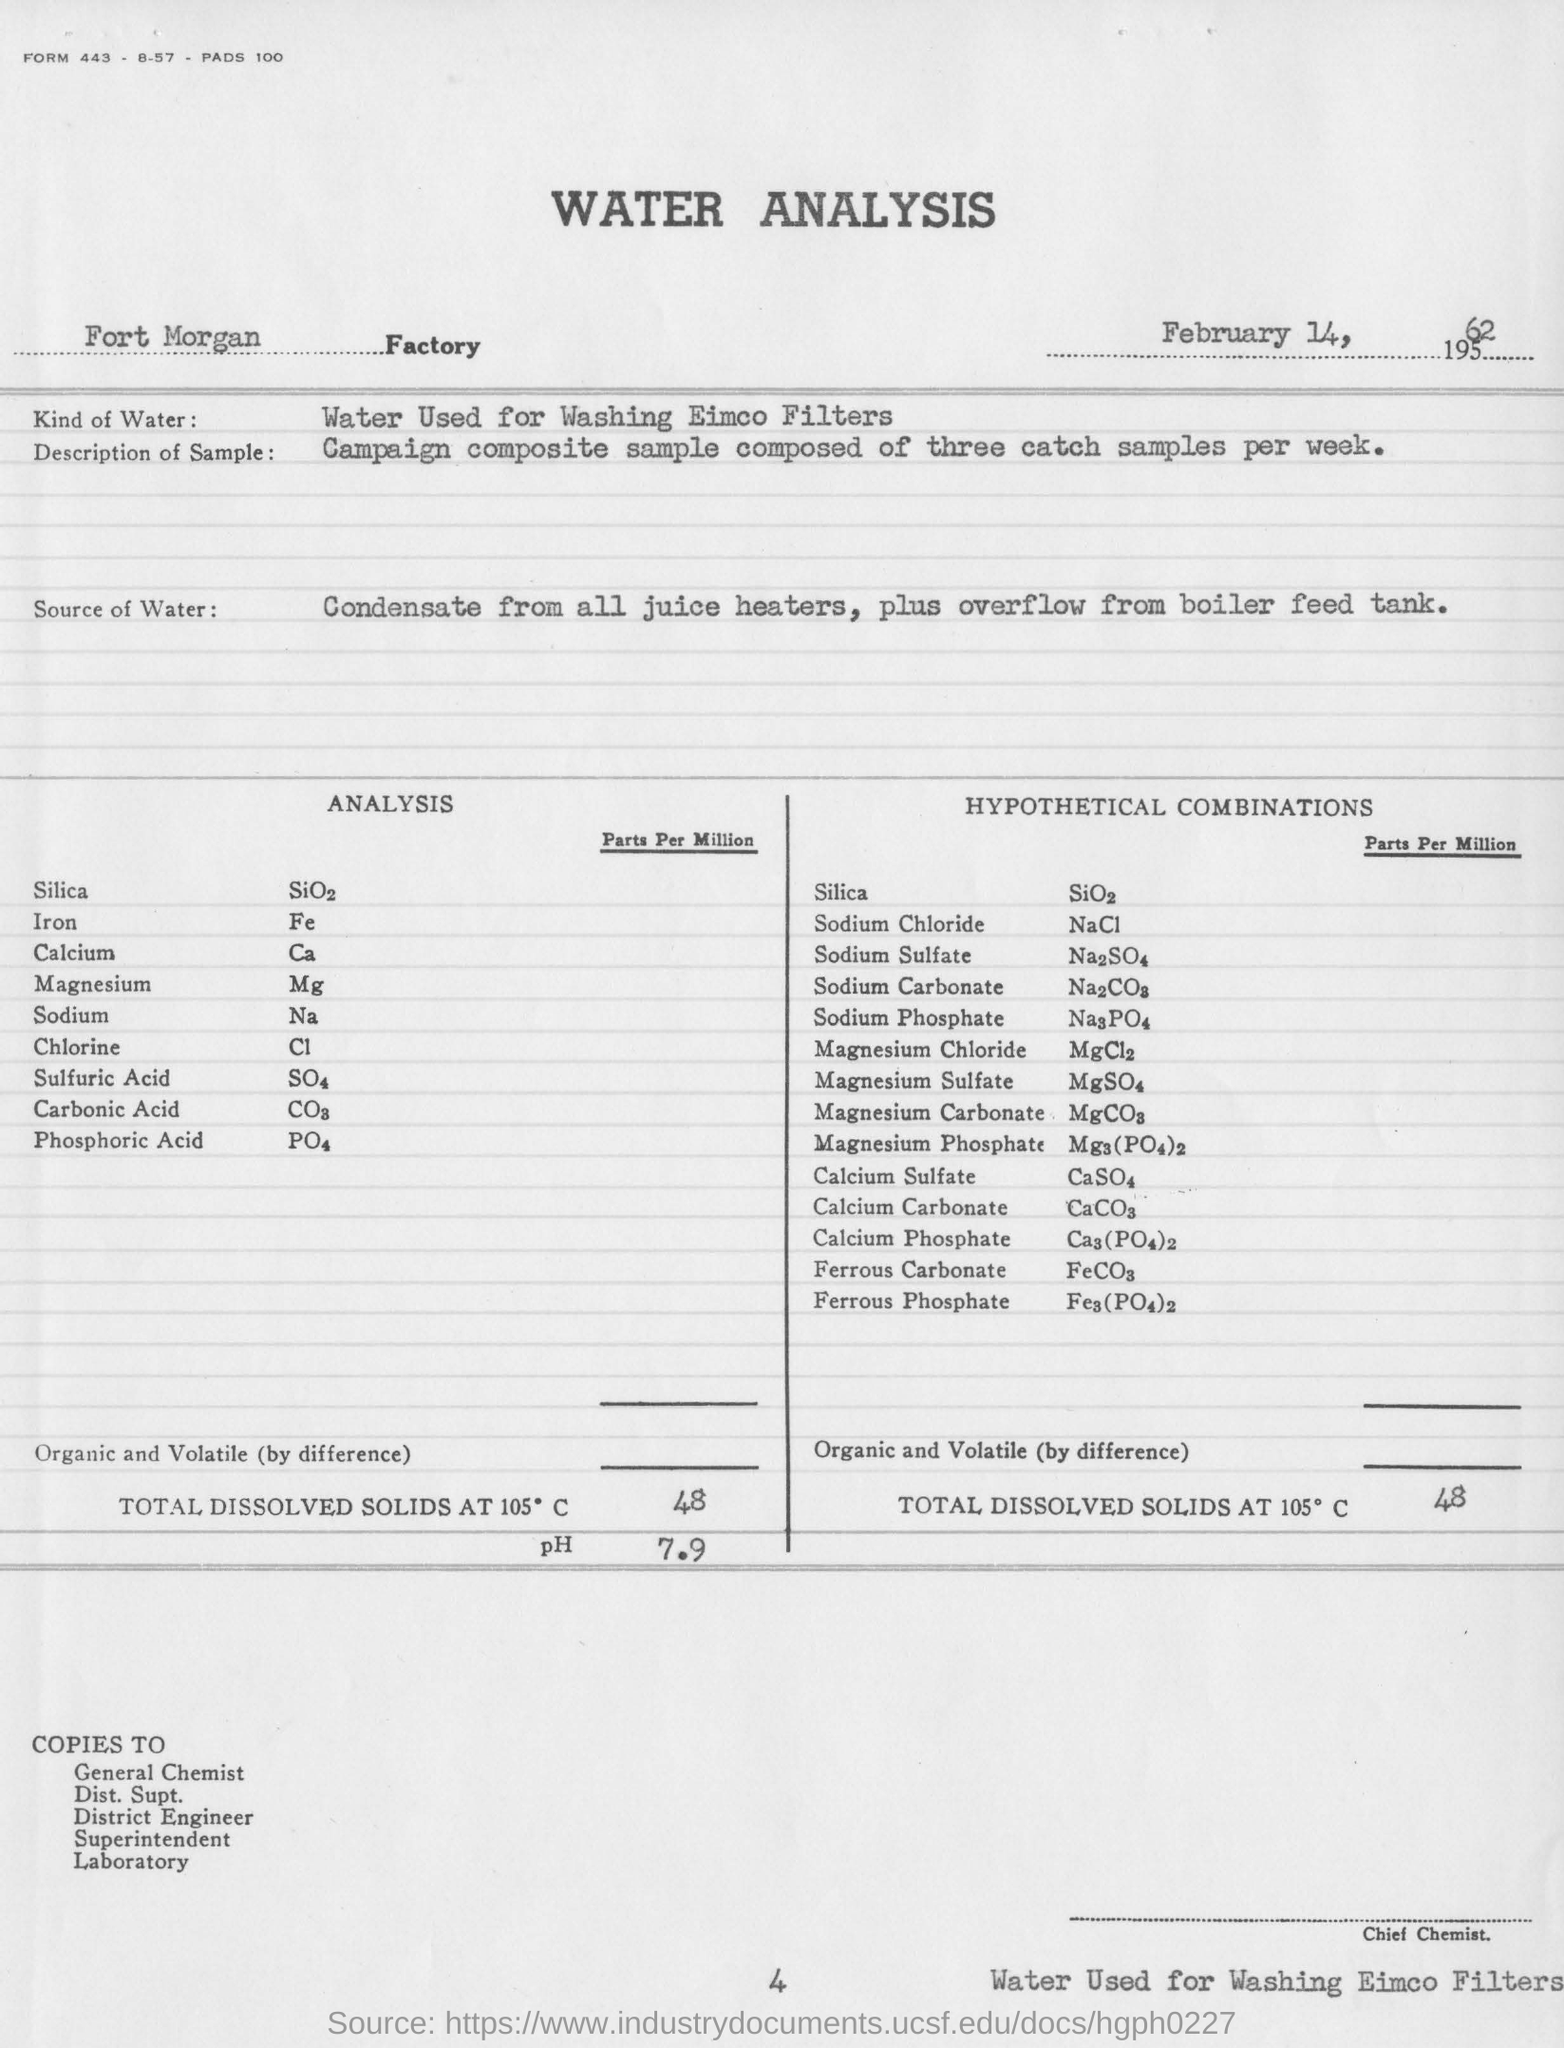In which factory samples are taken for water analysis test?
Provide a short and direct response. Fort morgan factory. Which filters are washed using water?
Ensure brevity in your answer.  EIMCO FILTERS. What is the third compound under the title of "analysis"?
Provide a succinct answer. CA. What is the ph value for sample in analysis?
Ensure brevity in your answer.  7.9. What is name of cl chemical compound ?
Ensure brevity in your answer.  CHLORINE. On which date fort morgan factory test was conducted?
Provide a short and direct response. FEBRUARY 14, 1962. What are the total dissolved solids at 105 degree c present in the hypothetical combination?
Your answer should be compact. 48. What is the formula for iron?
Offer a terse response. Fe. What is the formula for the sodium?
Offer a very short reply. Na. 